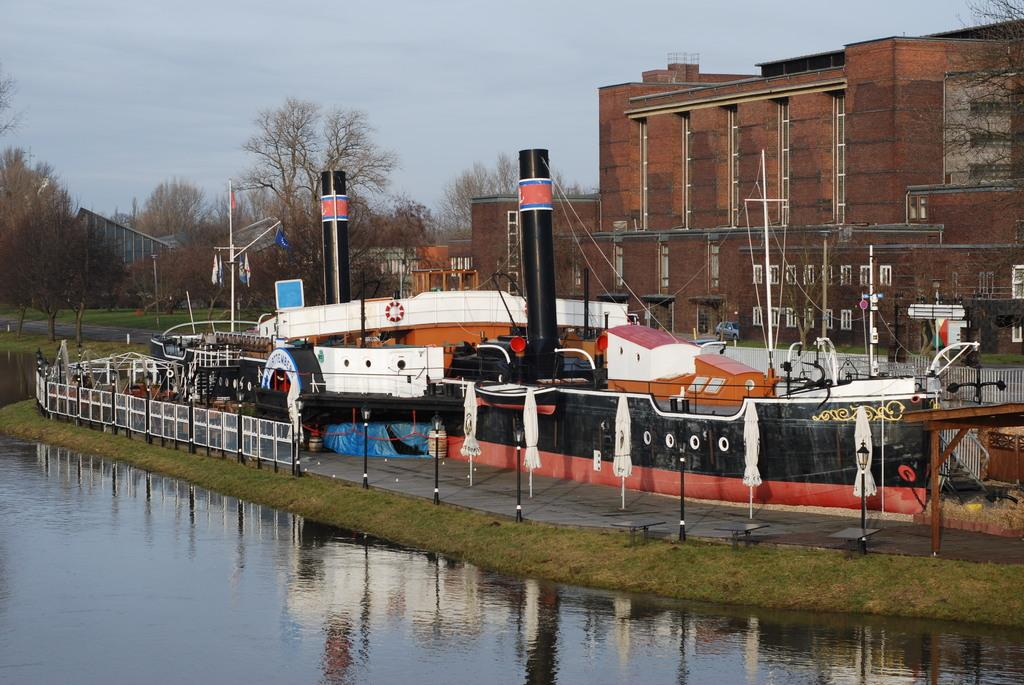What type of structures can be seen in the image? There are light poles, umbrellas, railings, a ship, trees, and buildings visible in the image. What is the weather like in the image? The sky is cloudy in the image, suggesting a potentially overcast or rainy day. Can you describe the distant object in the image? There is a vehicle far away in the image. What type of corn can be seen growing near the ship in the image? There is no corn visible in the image; it features a ship, light poles, umbrellas, railings, trees, and buildings. Are there any bears visible in the image? No, there are no bears present in the image. 